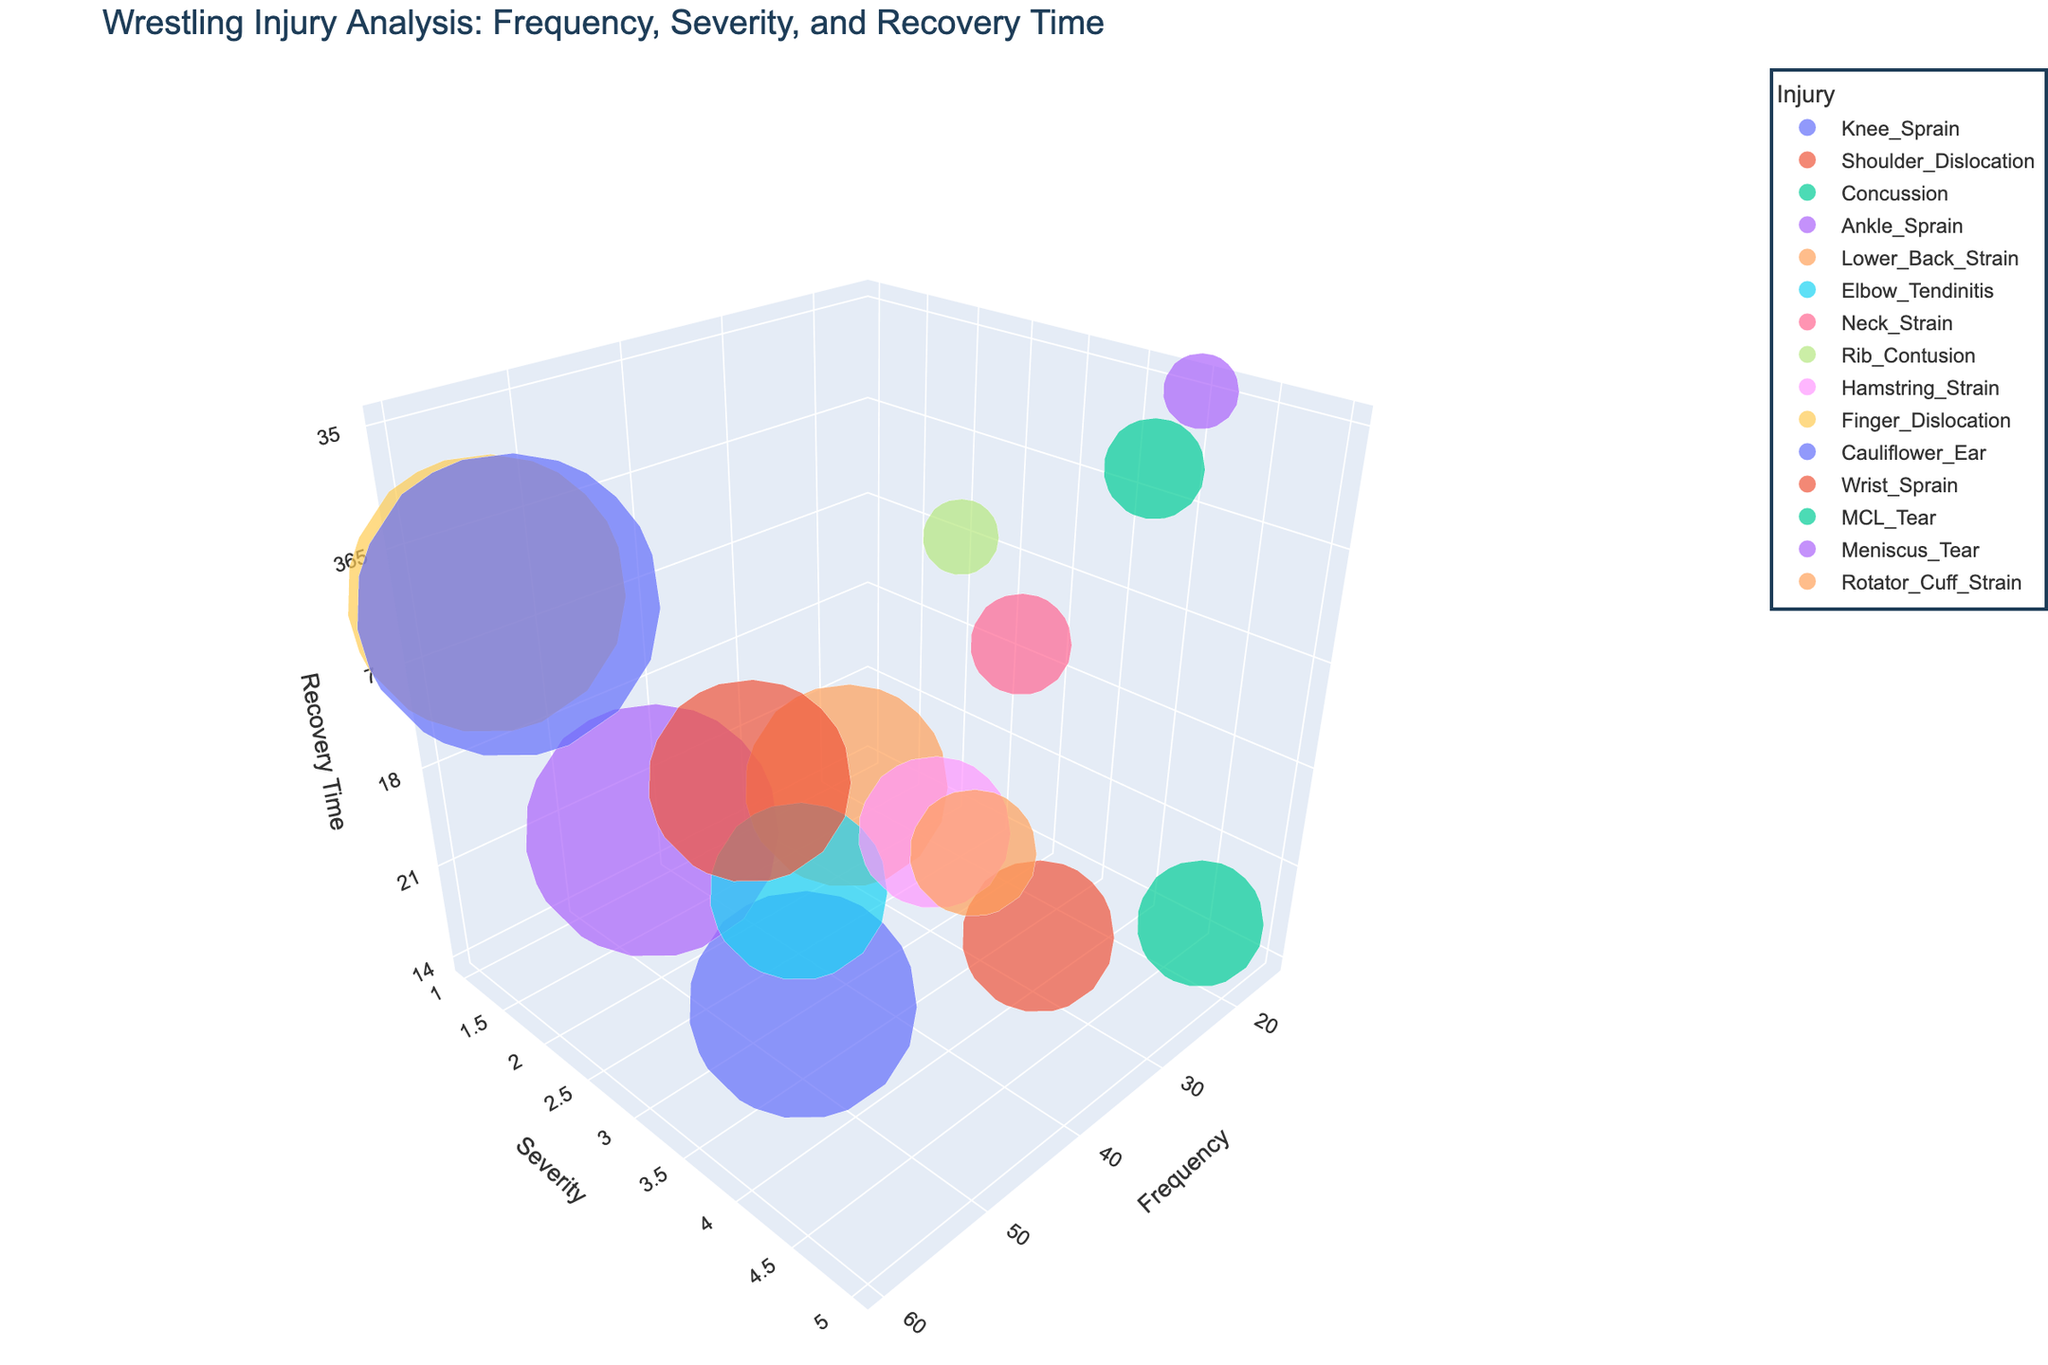What's the title of the figure? The title of the figure is typically displayed prominently at the top. By looking at the top of the figure, you can read the title.
Answer: Wrestling Injury Analysis: Frequency, Severity, and Recovery Time How many types of injuries are depicted in the figure? Each bubble represents a different type of injury, and the legend indicates the unique colors corresponding to different injuries. Count the distinct types of injuries listed in the legend.
Answer: 15 Which injury has the highest frequency? The frequency axis (X-axis) shows values along its scale. Locate the bubble that is the furthest to the right, as it represents the highest frequency. Check the legend or hover over it to identify the injury type.
Answer: Cauliflower Ear What's the approximate recovery time for an Ankle Sprain? The recovery time (Z-axis) shows values along its scale. Locate the bubble for Ankle Sprain, and then check its position along the Z-axis. Recovery time for Ankle Sprain is around 10 days.
Answer: 10 days Which injury has the highest severity rating? The severity axis (Y-axis) shows values along its scale. Locate the bubble that is the highest up on the Y-axis, as it represents the highest severity. Check the legend or hover over it to identify the injury type.
Answer: Concussion What's the average frequency of injuries with a severity rating of 4? Firstly, identify the injuries with a severity rating of 4. These include Shoulder Dislocation, MCL Tear, and Meniscus Tear. Their frequencies are 30, 20, and 15 respectively. Sum these frequencies and divide by the number of injuries.
Answer: 21.67 How does the recovery time for Shoulder Dislocation compare to Rotator Cuff Strain? Locate the bubbles for Shoulder Dislocation and Rotator Cuff Strain along the Z-axis. Shoulder Dislocation is at 28 days, and Rotator Cuff Strain is also at 28 days. So, the recovery times are equal.
Answer: Equal Which injury has the shortest recovery time? The recovery time axis (Z-axis) shows values along its scale. Locate the bubble that is closest to the origin of the Z-axis to determine the shortest recovery time.
Answer: Finger Dislocation Do injuries with the highest severity always have the longest recovery times? Look at the positions of bubbles with the highest severity (Y-axis value 5). Compare their positions on the Z-axis. Concussion has high severity but not the longest recovery time (21 days). Therefore, the trend is not absolute.
Answer: No Which injuries have the same severity and recovery time but different frequencies? Locate injuries that align similarly on the Y-axis (severity) and the Z-axis (recovery time). Elbow Tendinitis and Knee Sprain both have a severity of 2 and recovery time of 14 days but different frequencies (35 and 45 respectively).
Answer: Elbow Tendinitis and Knee Sprain 